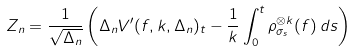Convert formula to latex. <formula><loc_0><loc_0><loc_500><loc_500>Z _ { n } = \frac { 1 } { \sqrt { \Delta _ { n } } } \left ( \Delta _ { n } V ^ { \prime } ( f , k , \Delta _ { n } ) _ { t } - \frac { 1 } { k } \int _ { 0 } ^ { t } \rho _ { \sigma _ { s } } ^ { \otimes k } ( f ) \, d s \right )</formula> 